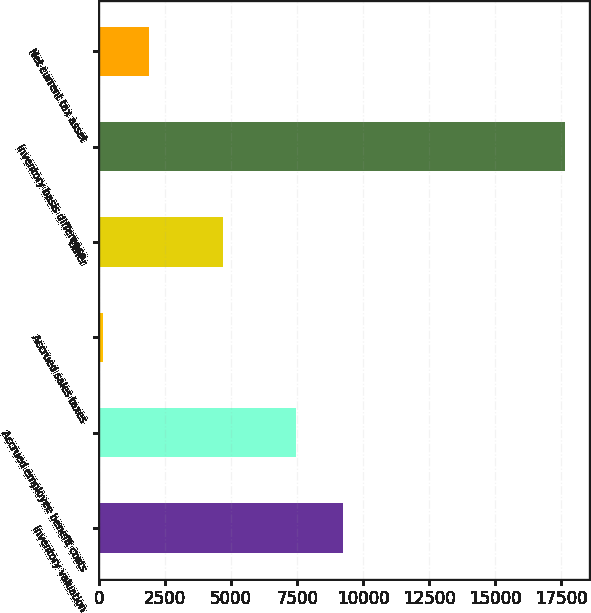Convert chart to OTSL. <chart><loc_0><loc_0><loc_500><loc_500><bar_chart><fcel>Inventory valuation<fcel>Accrued employee benefit costs<fcel>Accrued sales taxes<fcel>Other<fcel>Inventory basis difference<fcel>Net current tax asset<nl><fcel>9217.4<fcel>7466<fcel>139<fcel>4671<fcel>17653<fcel>1890.4<nl></chart> 